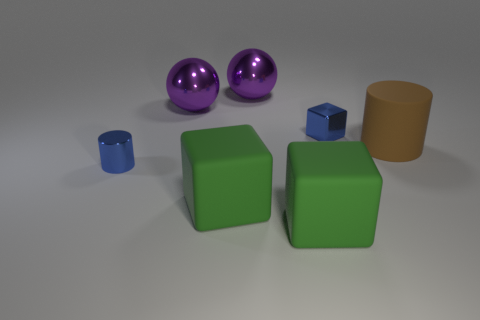Subtract all blue cubes. How many cubes are left? 2 Add 3 large cylinders. How many objects exist? 10 Subtract all yellow spheres. How many green blocks are left? 2 Subtract all blue blocks. How many blocks are left? 2 Subtract all balls. How many objects are left? 5 Subtract 1 blue cylinders. How many objects are left? 6 Subtract all cyan spheres. Subtract all red blocks. How many spheres are left? 2 Subtract all big cylinders. Subtract all tiny blue cylinders. How many objects are left? 5 Add 6 brown things. How many brown things are left? 7 Add 3 large green rubber blocks. How many large green rubber blocks exist? 5 